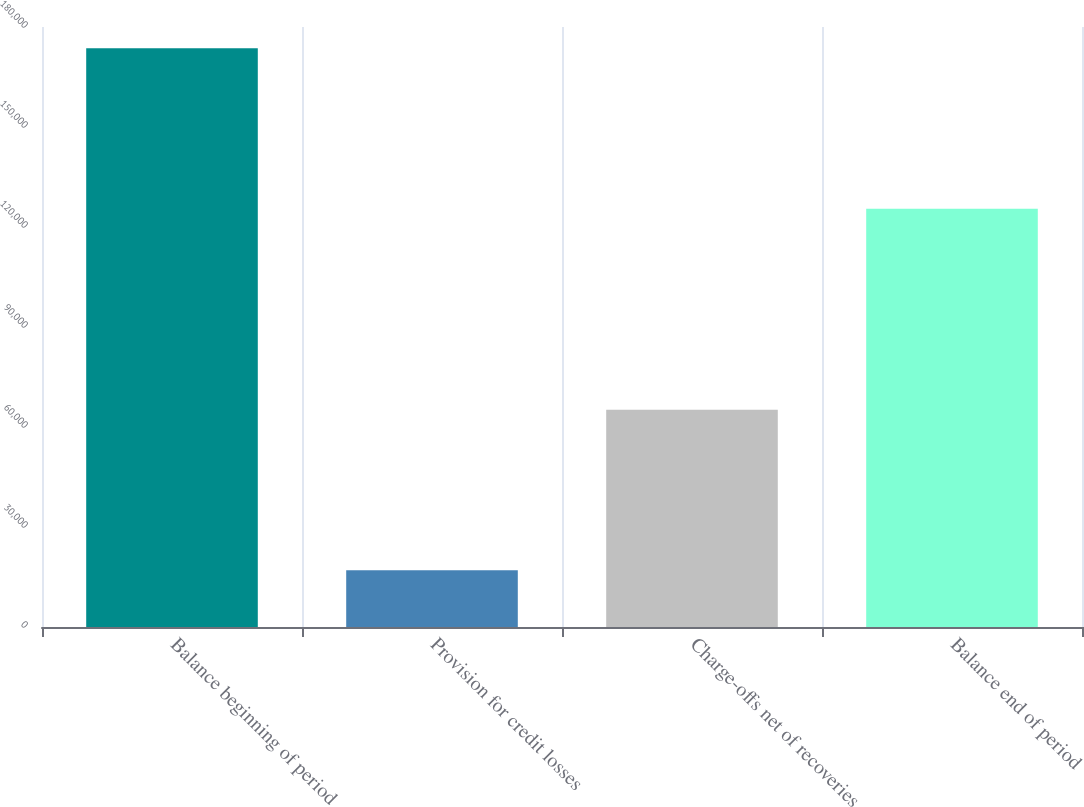Convert chart. <chart><loc_0><loc_0><loc_500><loc_500><bar_chart><fcel>Balance beginning of period<fcel>Provision for credit losses<fcel>Charge-offs net of recoveries<fcel>Balance end of period<nl><fcel>173589<fcel>17031<fcel>65171<fcel>125449<nl></chart> 